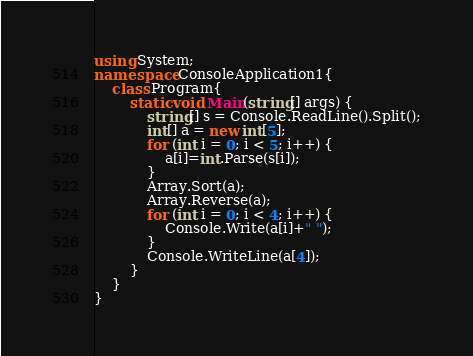<code> <loc_0><loc_0><loc_500><loc_500><_C#_>using System;
namespace ConsoleApplication1{
    class Program{
        static void Main(string[] args) {
            string[] s = Console.ReadLine().Split();
            int[] a = new int[5];
            for (int i = 0; i < 5; i++) {
                a[i]=int.Parse(s[i]);
            }
            Array.Sort(a);
            Array.Reverse(a);
            for (int i = 0; i < 4; i++) {
                Console.Write(a[i]+" ");
            }
            Console.WriteLine(a[4]);
        }
    }
}</code> 